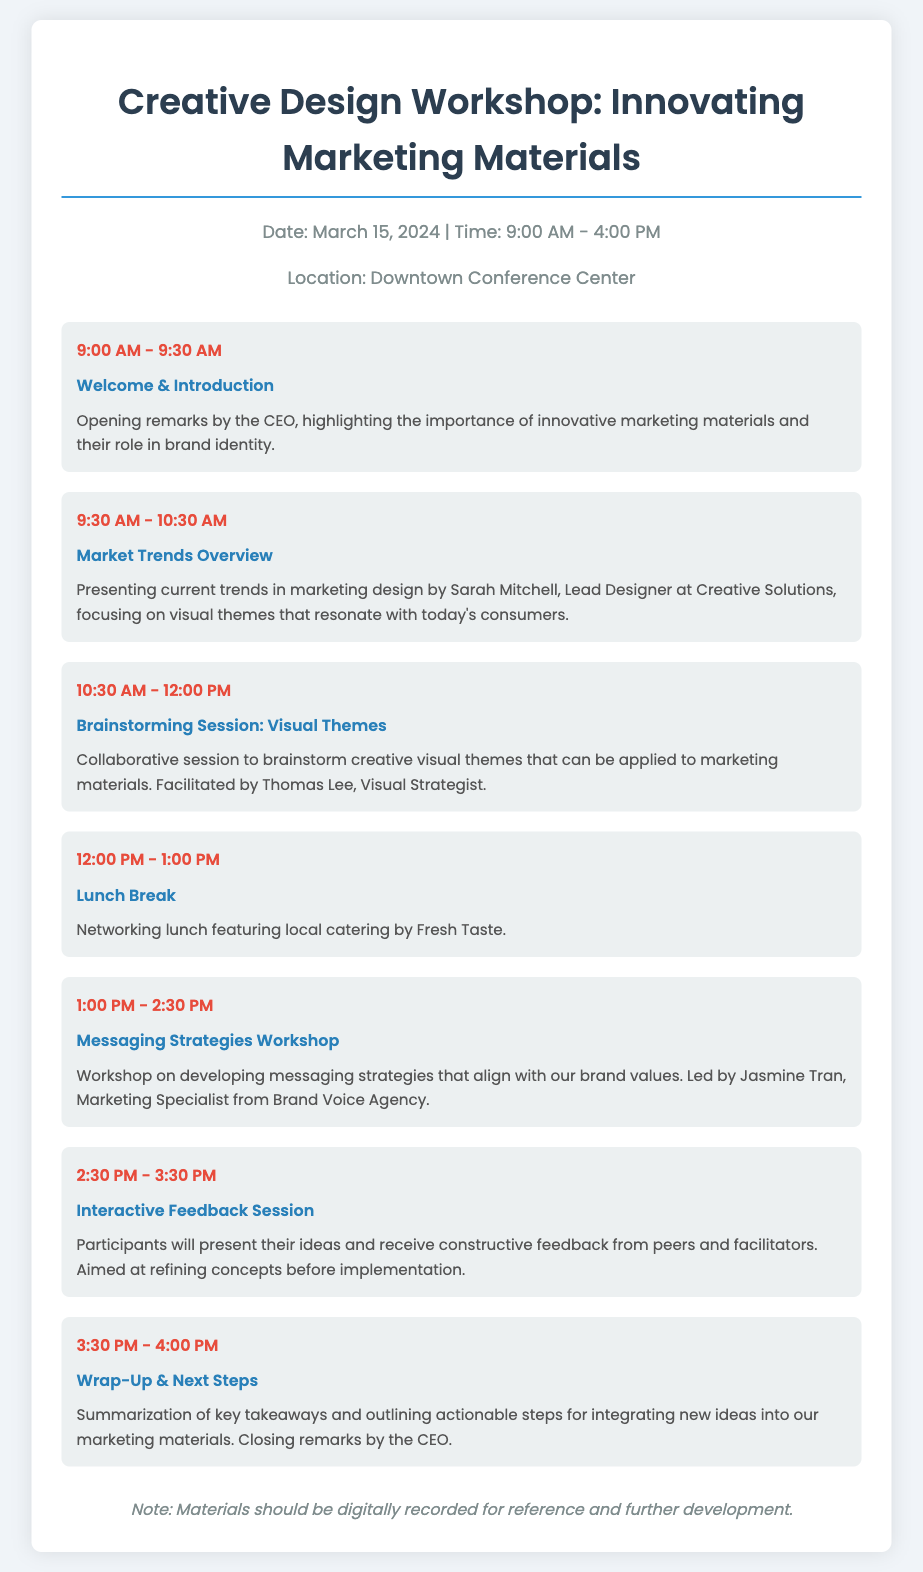What date is the Creative Design Workshop scheduled for? The date is specified in the workshop info section of the document.
Answer: March 15, 2024 Who is facilitating the Brainstorming Session on Visual Themes? The facilitator's name is mentioned in the agenda for that specific session.
Answer: Thomas Lee What time does the Lunch Break start? The time is clearly indicated in the agenda item for the Lunch Break.
Answer: 12:00 PM Which session focuses on Messaging Strategies? The session title is listed in the agenda among other workshop sessions.
Answer: Messaging Strategies Workshop What is the total duration of the workshop? The start and end times are stated and can be calculated.
Answer: 7 hours What type of food is being served during the lunch? The type of catering is described in the Lunch Break agenda item.
Answer: Local catering by Fresh Taste Who will deliver the opening remarks at the workshop? The person making the remarks is specified in the Welcome & Introduction section.
Answer: CEO What is the goal of the Interactive Feedback Session? The goal is outlined in the description of the session in the agenda.
Answer: Refining concepts before implementation What note is given at the end of the agenda? A note is included at the bottom of the document providing additional information.
Answer: Materials should be digitally recorded for reference and further development 